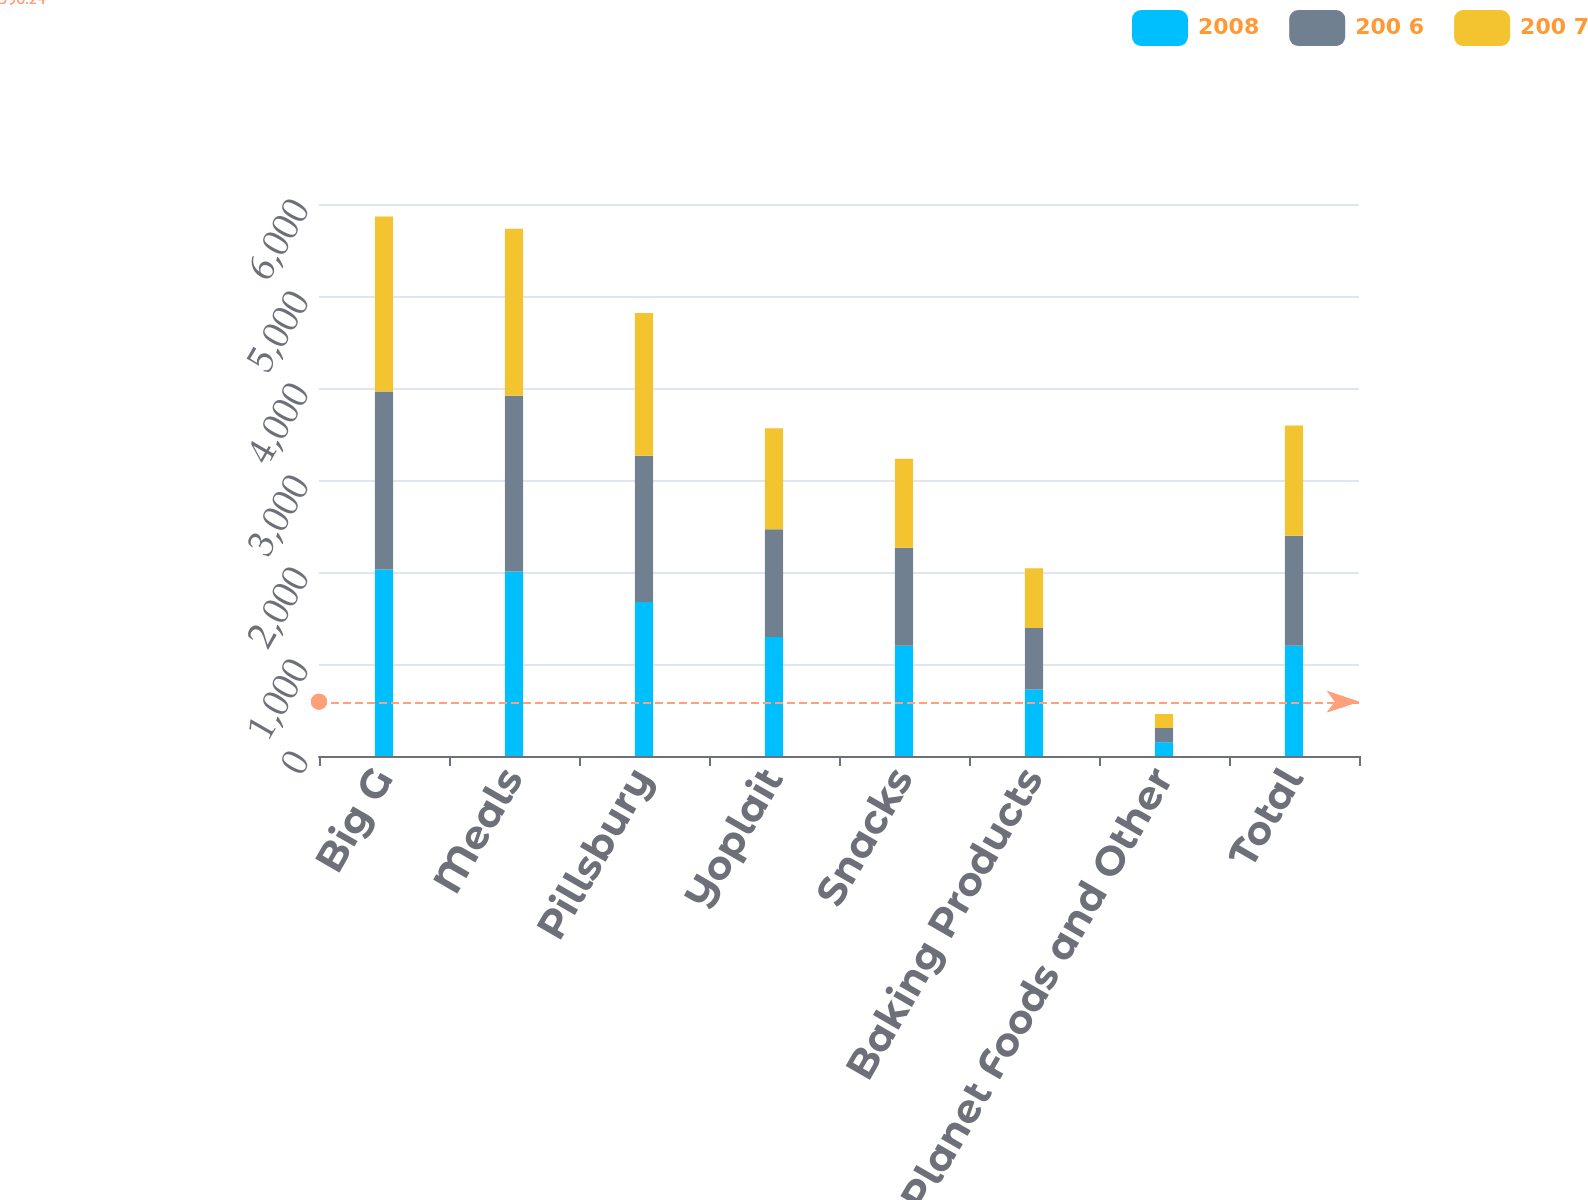Convert chart. <chart><loc_0><loc_0><loc_500><loc_500><stacked_bar_chart><ecel><fcel>Big G<fcel>Meals<fcel>Pillsbury<fcel>Yoplait<fcel>Snacks<fcel>Baking Products<fcel>Small Planet Foods and Other<fcel>Total<nl><fcel>2008<fcel>2028<fcel>2006.1<fcel>1673.4<fcel>1293.1<fcel>1197.6<fcel>723.3<fcel>150.5<fcel>1197.6<nl><fcel>200 6<fcel>1932.9<fcel>1909.2<fcel>1591.4<fcel>1170.7<fcel>1066.5<fcel>666.7<fcel>153.9<fcel>1197.6<nl><fcel>200 7<fcel>1902.3<fcel>1815.4<fcel>1549.8<fcel>1099.4<fcel>967.3<fcel>650.2<fcel>151.9<fcel>1197.6<nl></chart> 